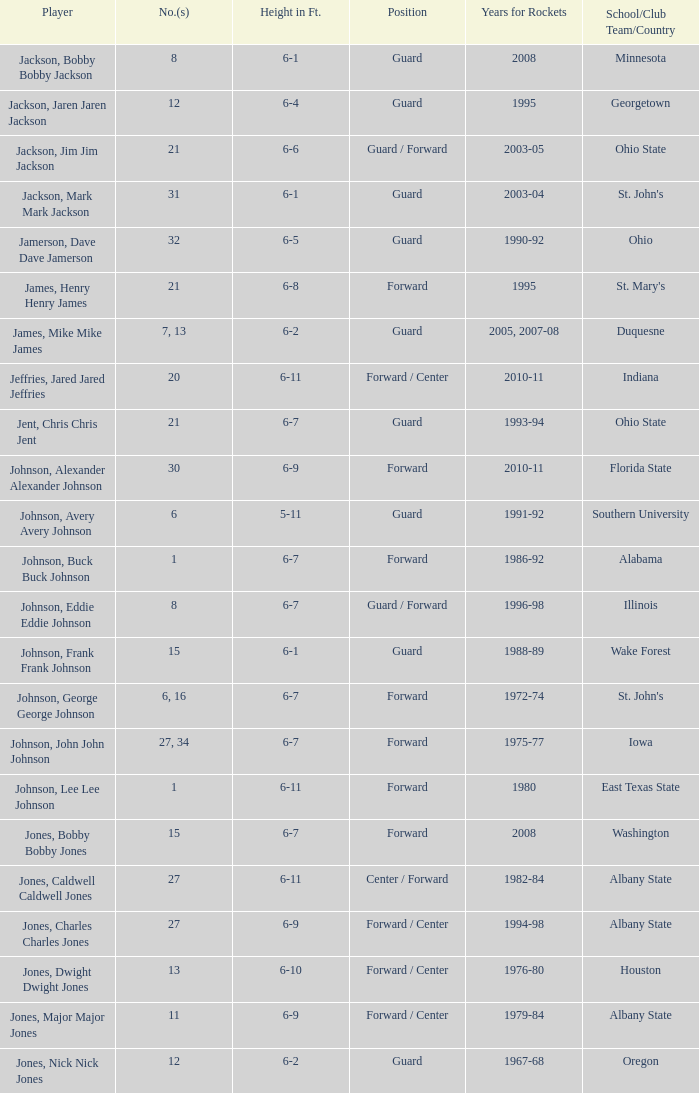What's the stature of the player jones, major major jones? 6-9. 